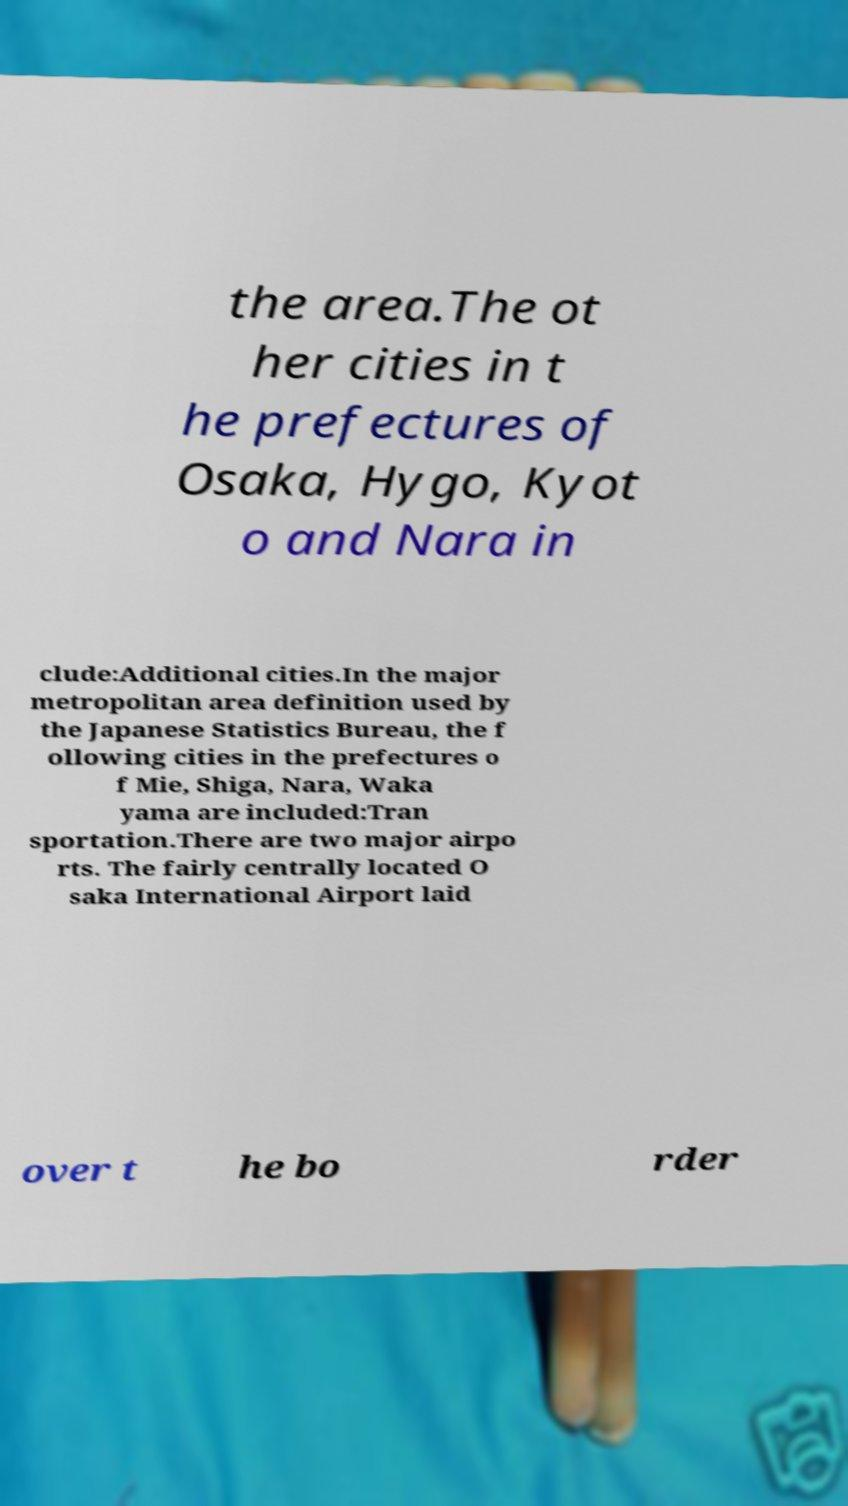I need the written content from this picture converted into text. Can you do that? the area.The ot her cities in t he prefectures of Osaka, Hygo, Kyot o and Nara in clude:Additional cities.In the major metropolitan area definition used by the Japanese Statistics Bureau, the f ollowing cities in the prefectures o f Mie, Shiga, Nara, Waka yama are included:Tran sportation.There are two major airpo rts. The fairly centrally located O saka International Airport laid over t he bo rder 